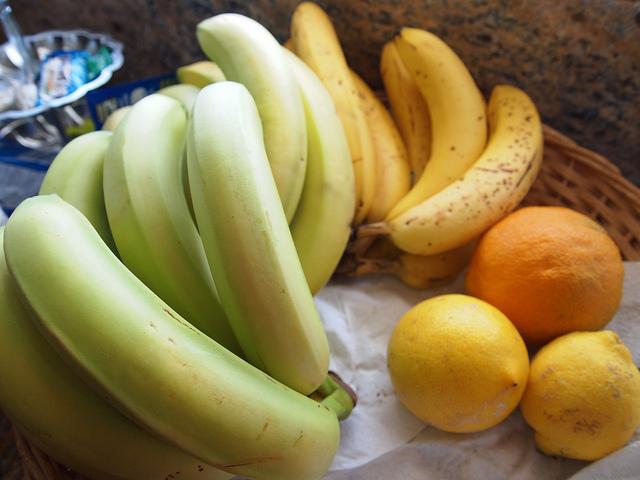What are fruits contained in?
Concise answer only. Basket. How many different types of fruit are there?
Short answer required. 2. What is the yellow fruit?
Quick response, please. Bananas and lemons. How many lemons are there?
Answer briefly. 2. Are they ripe?
Be succinct. Yes. Which bananas are newer?
Give a very brief answer. Left. 